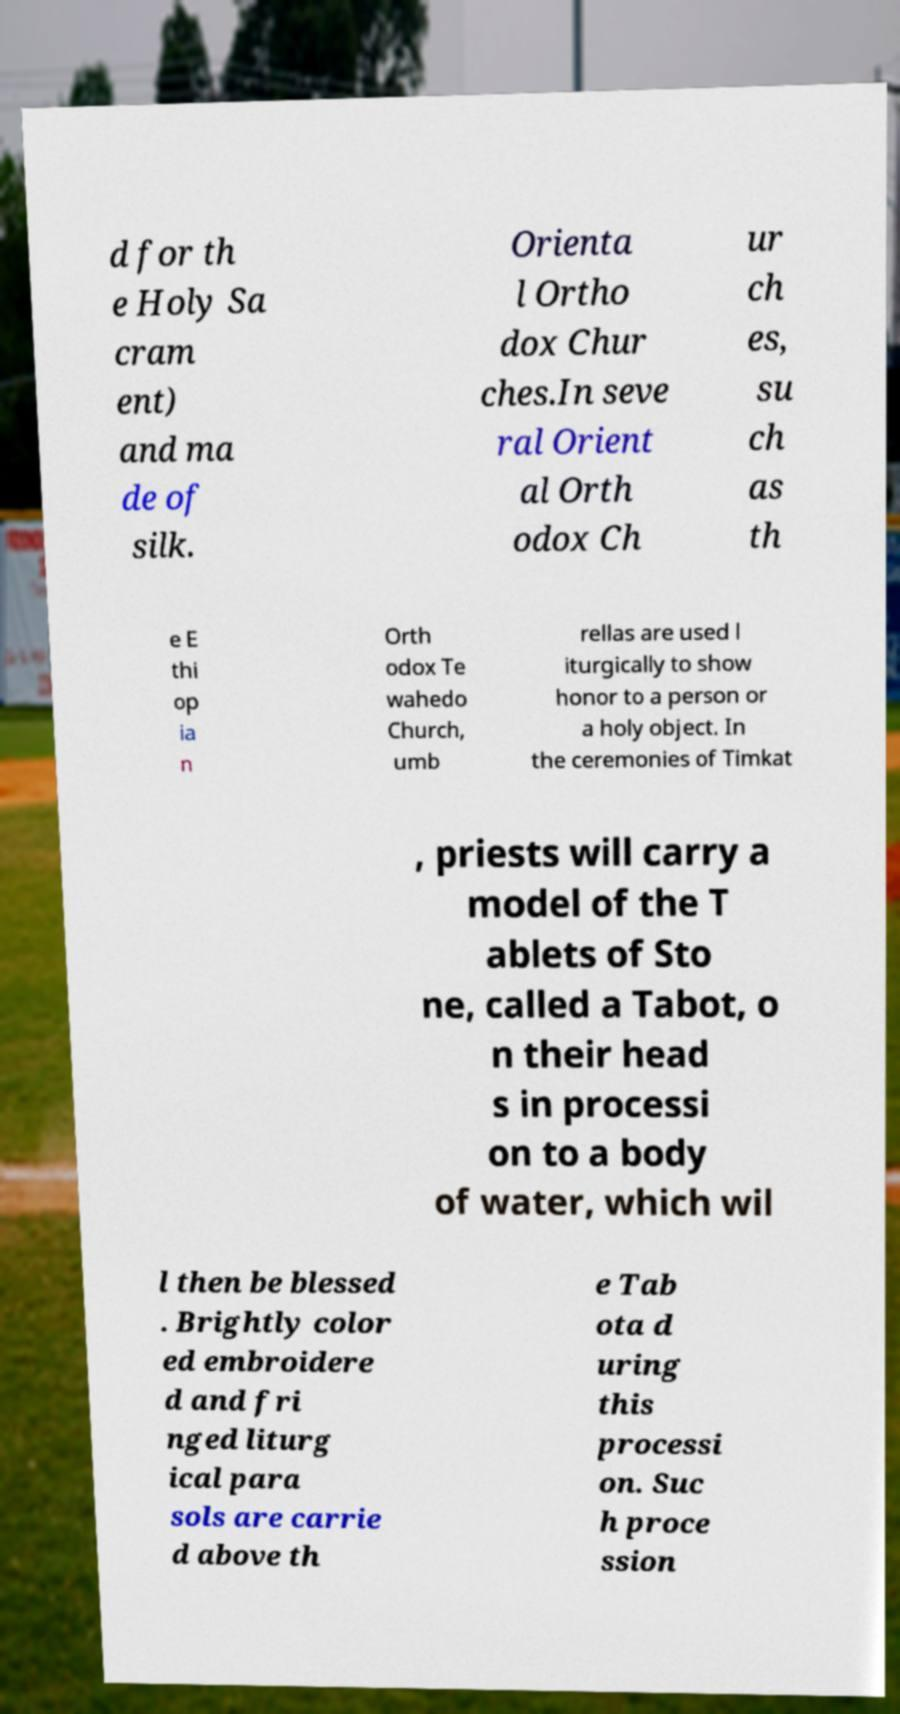For documentation purposes, I need the text within this image transcribed. Could you provide that? d for th e Holy Sa cram ent) and ma de of silk. Orienta l Ortho dox Chur ches.In seve ral Orient al Orth odox Ch ur ch es, su ch as th e E thi op ia n Orth odox Te wahedo Church, umb rellas are used l iturgically to show honor to a person or a holy object. In the ceremonies of Timkat , priests will carry a model of the T ablets of Sto ne, called a Tabot, o n their head s in processi on to a body of water, which wil l then be blessed . Brightly color ed embroidere d and fri nged liturg ical para sols are carrie d above th e Tab ota d uring this processi on. Suc h proce ssion 